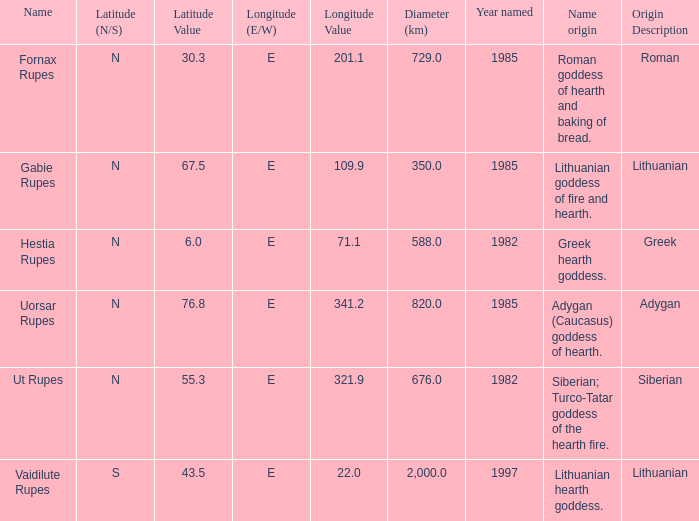At a latitude of 67.5n, what is the diameter? 350.0. 